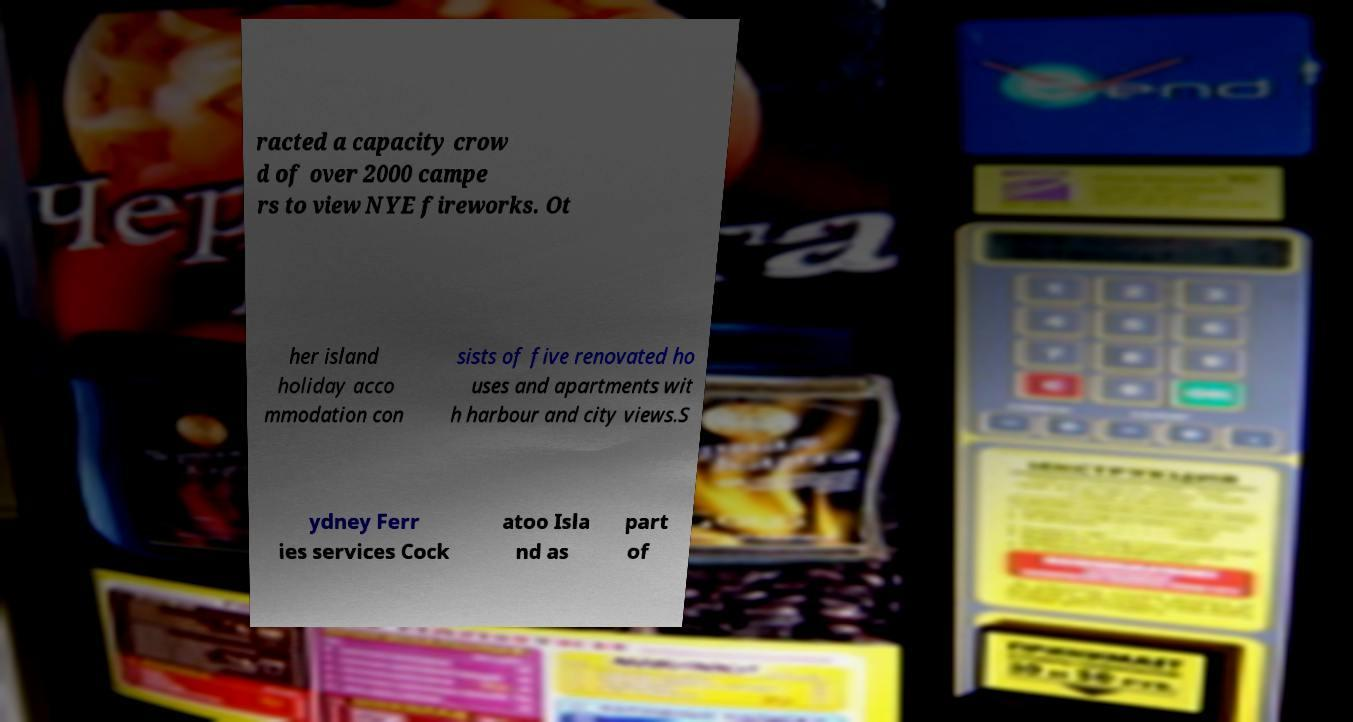Can you read and provide the text displayed in the image?This photo seems to have some interesting text. Can you extract and type it out for me? racted a capacity crow d of over 2000 campe rs to view NYE fireworks. Ot her island holiday acco mmodation con sists of five renovated ho uses and apartments wit h harbour and city views.S ydney Ferr ies services Cock atoo Isla nd as part of 